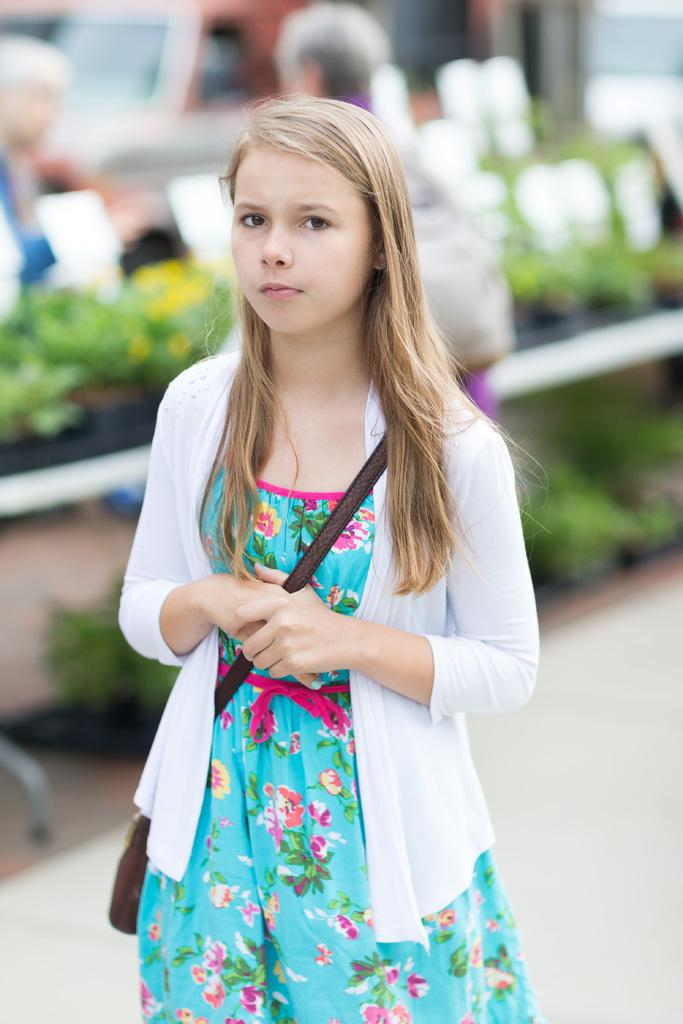Who is the main subject in the image? There is a girl in the image. What is the girl holding or carrying? The girl is carrying a bag. What can be seen in the background of the image? There are plants, two people, and a vehicle in the background of the image. How would you describe the overall quality of the image? The image is blurry. What type of house can be seen in the alley behind the girl? There is no alley or house present in the image. 